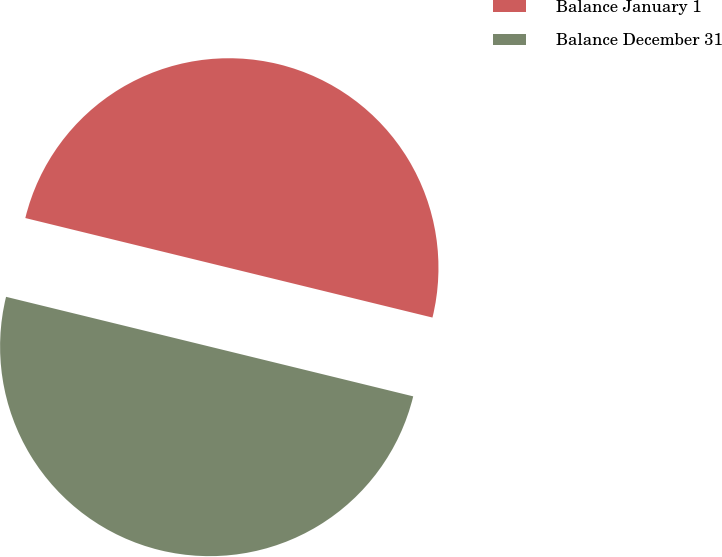Convert chart. <chart><loc_0><loc_0><loc_500><loc_500><pie_chart><fcel>Balance January 1<fcel>Balance December 31<nl><fcel>50.0%<fcel>50.0%<nl></chart> 